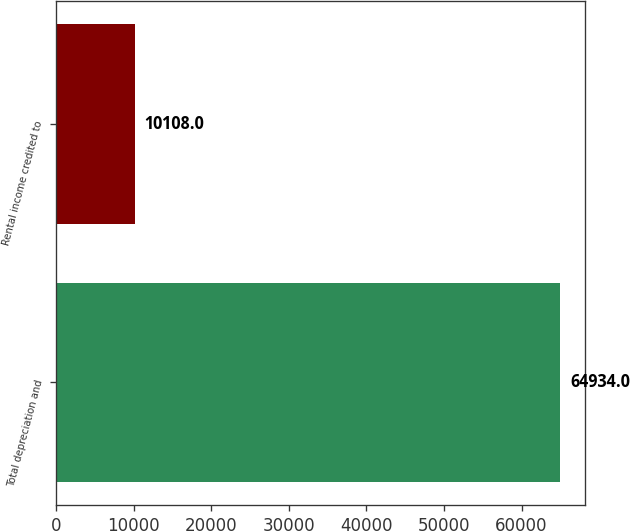<chart> <loc_0><loc_0><loc_500><loc_500><bar_chart><fcel>Total depreciation and<fcel>Rental income credited to<nl><fcel>64934<fcel>10108<nl></chart> 